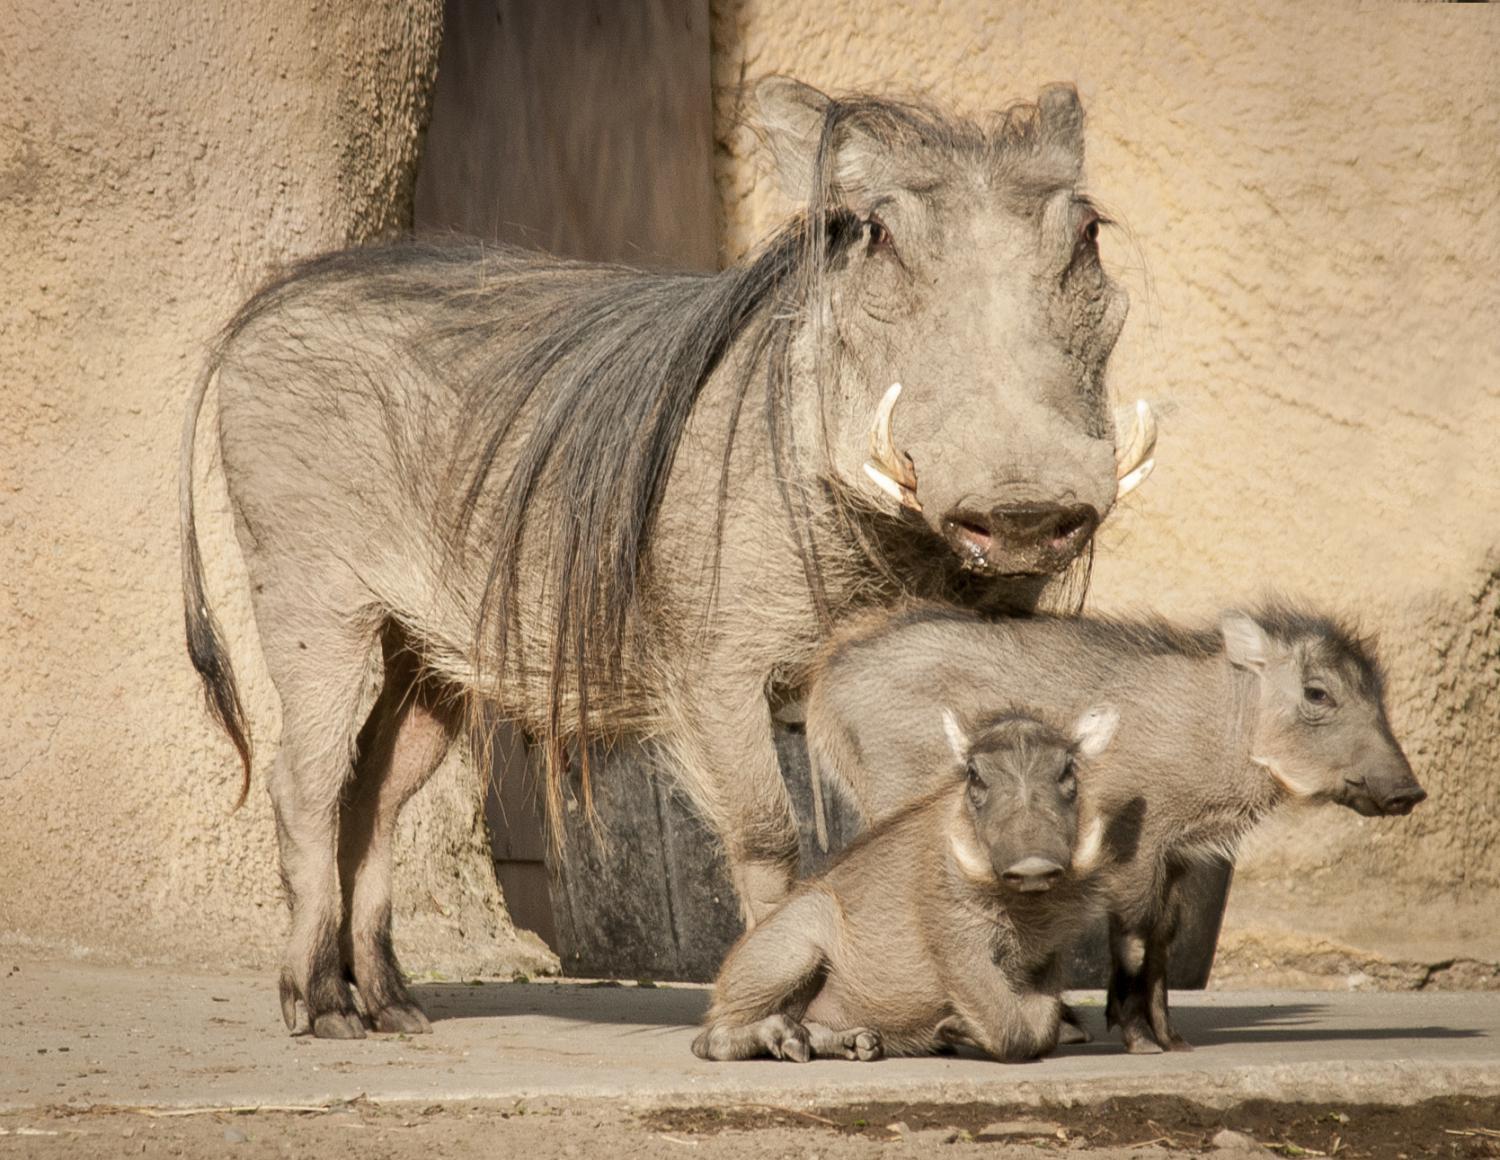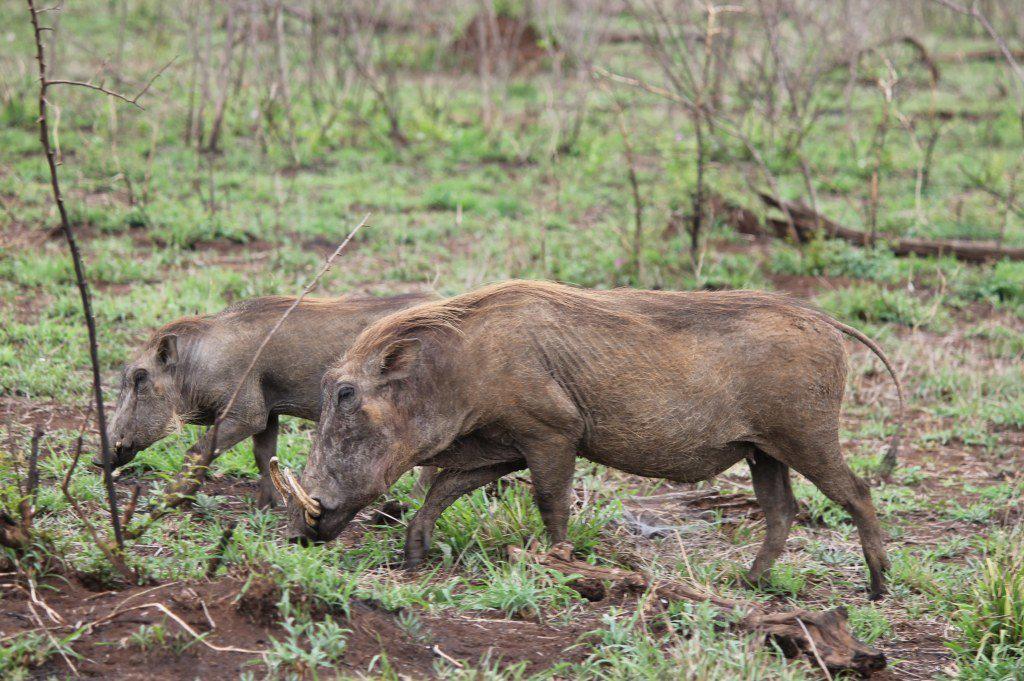The first image is the image on the left, the second image is the image on the right. For the images shown, is this caption "Both images show a pair of warthogs posed face-to-face." true? Answer yes or no. No. The first image is the image on the left, the second image is the image on the right. For the images shown, is this caption "There are two pairs of warthogs standing with their faces touching." true? Answer yes or no. No. 